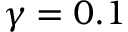<formula> <loc_0><loc_0><loc_500><loc_500>\gamma = 0 . 1</formula> 